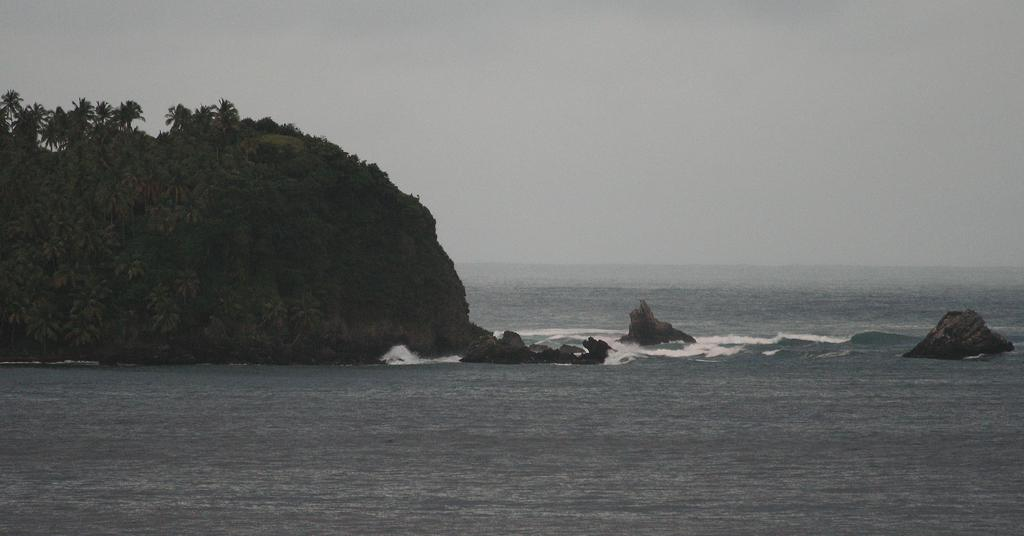What type of natural landscape is depicted in the image? The image features trees and plants on a mountain. What is the relationship between the mountain and the water in the image? The mountain is in the water. What can be seen on the right side of the image? There are rocks on the right side of the image. What is visible in the background of the image? The sky is visible in the background of the image. What language is spoken by the pot in the image? There is no pot present in the image, and therefore no language can be attributed to it. 